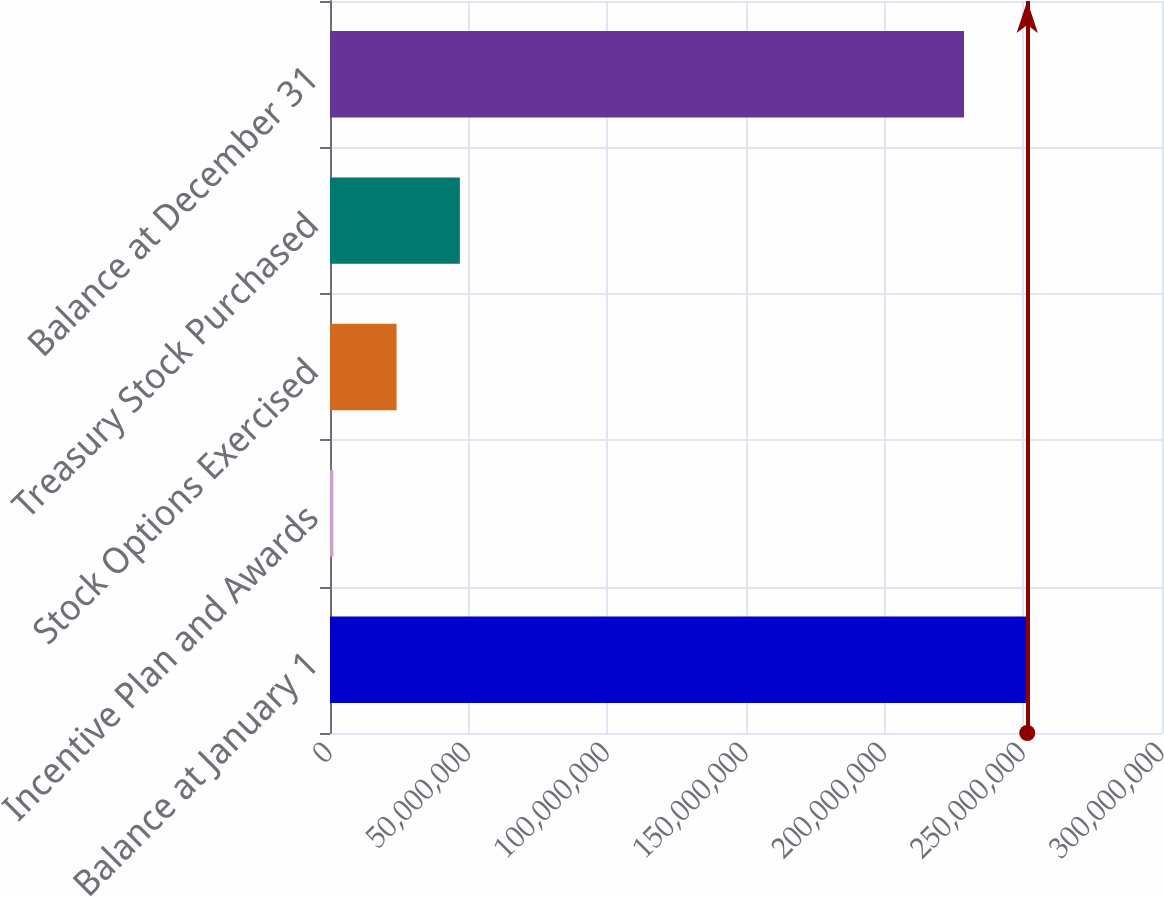Convert chart. <chart><loc_0><loc_0><loc_500><loc_500><bar_chart><fcel>Balance at January 1<fcel>Incentive Plan and Awards<fcel>Stock Options Exercised<fcel>Treasury Stock Purchased<fcel>Balance at December 31<nl><fcel>2.51414e+08<fcel>1.20912e+06<fcel>2.40176e+07<fcel>4.68261e+07<fcel>2.28605e+08<nl></chart> 